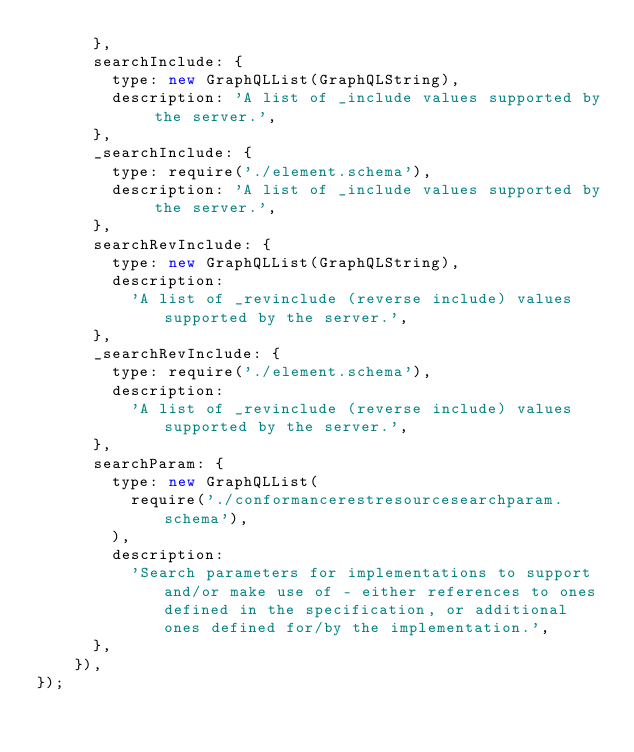Convert code to text. <code><loc_0><loc_0><loc_500><loc_500><_JavaScript_>			},
			searchInclude: {
				type: new GraphQLList(GraphQLString),
				description: 'A list of _include values supported by the server.',
			},
			_searchInclude: {
				type: require('./element.schema'),
				description: 'A list of _include values supported by the server.',
			},
			searchRevInclude: {
				type: new GraphQLList(GraphQLString),
				description:
					'A list of _revinclude (reverse include) values supported by the server.',
			},
			_searchRevInclude: {
				type: require('./element.schema'),
				description:
					'A list of _revinclude (reverse include) values supported by the server.',
			},
			searchParam: {
				type: new GraphQLList(
					require('./conformancerestresourcesearchparam.schema'),
				),
				description:
					'Search parameters for implementations to support and/or make use of - either references to ones defined in the specification, or additional ones defined for/by the implementation.',
			},
		}),
});
</code> 